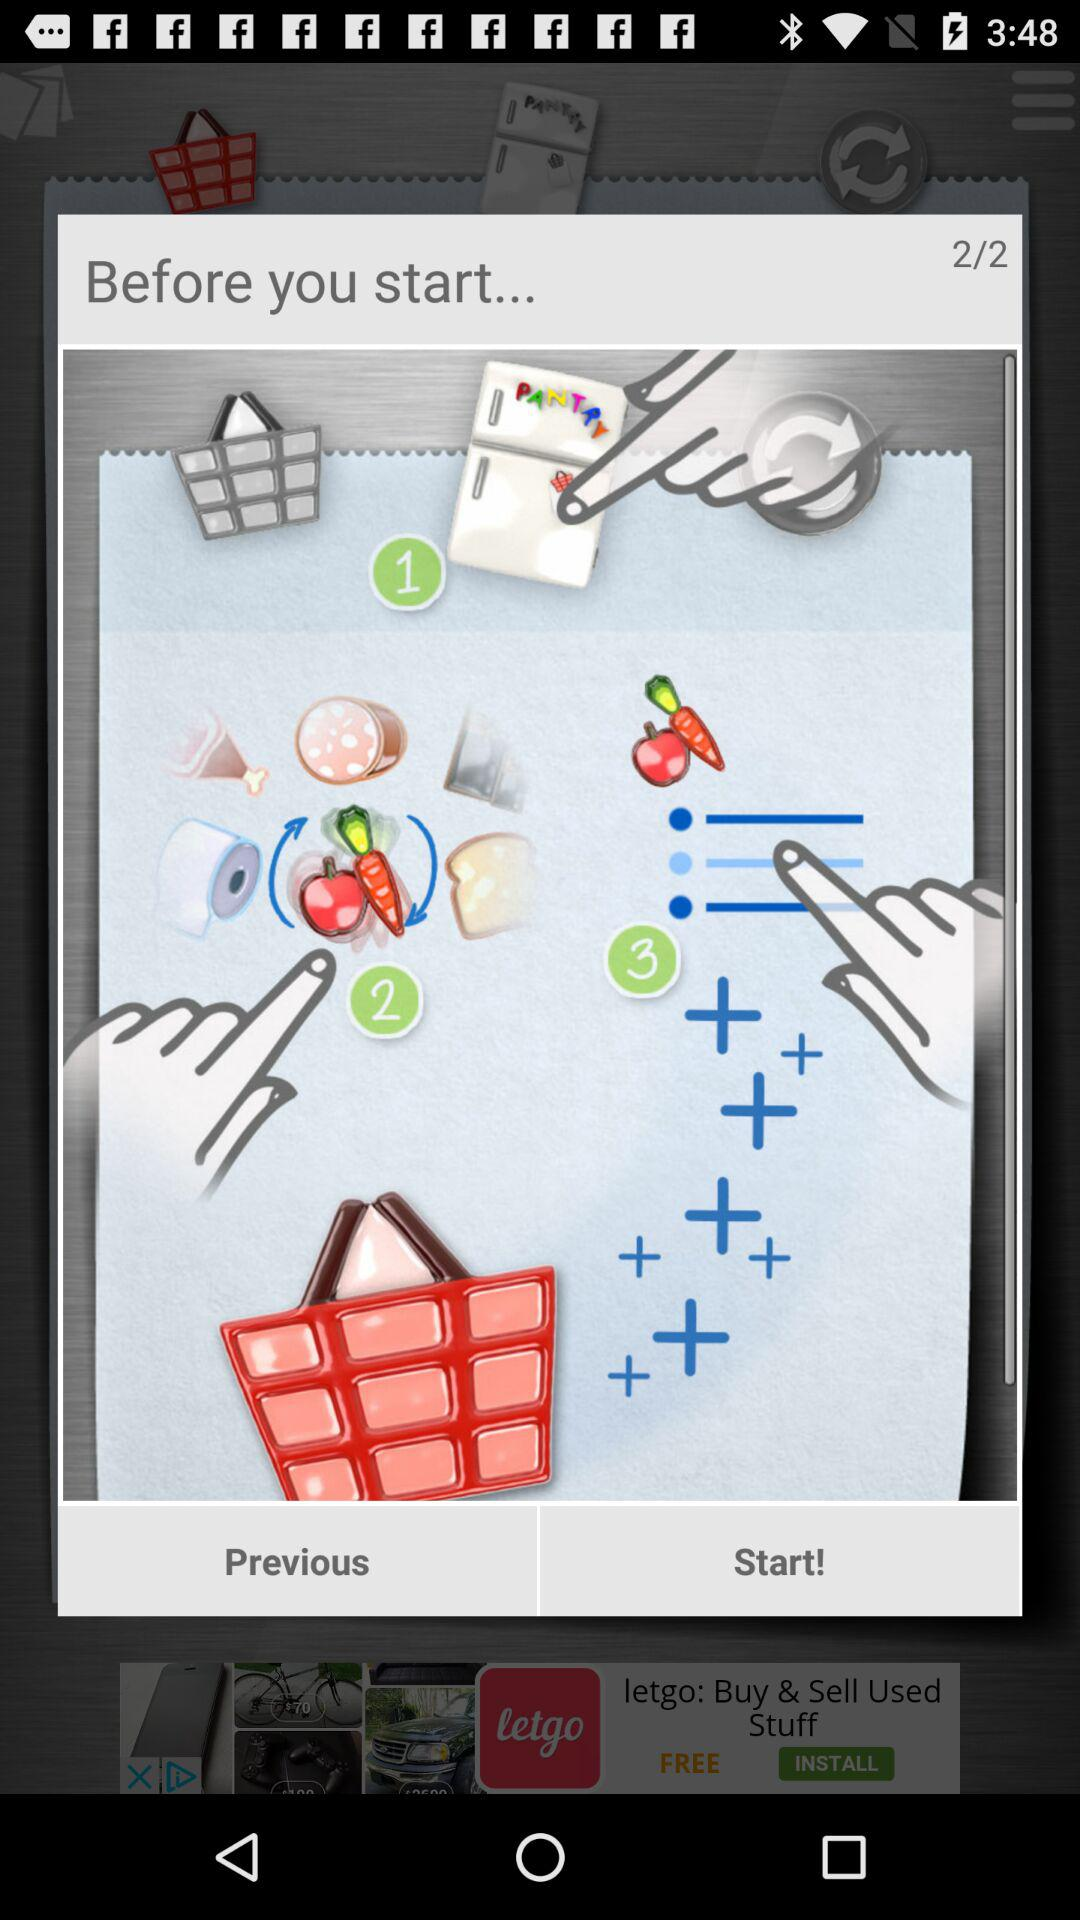How many pages in total are there? There are 2 pages in total. 